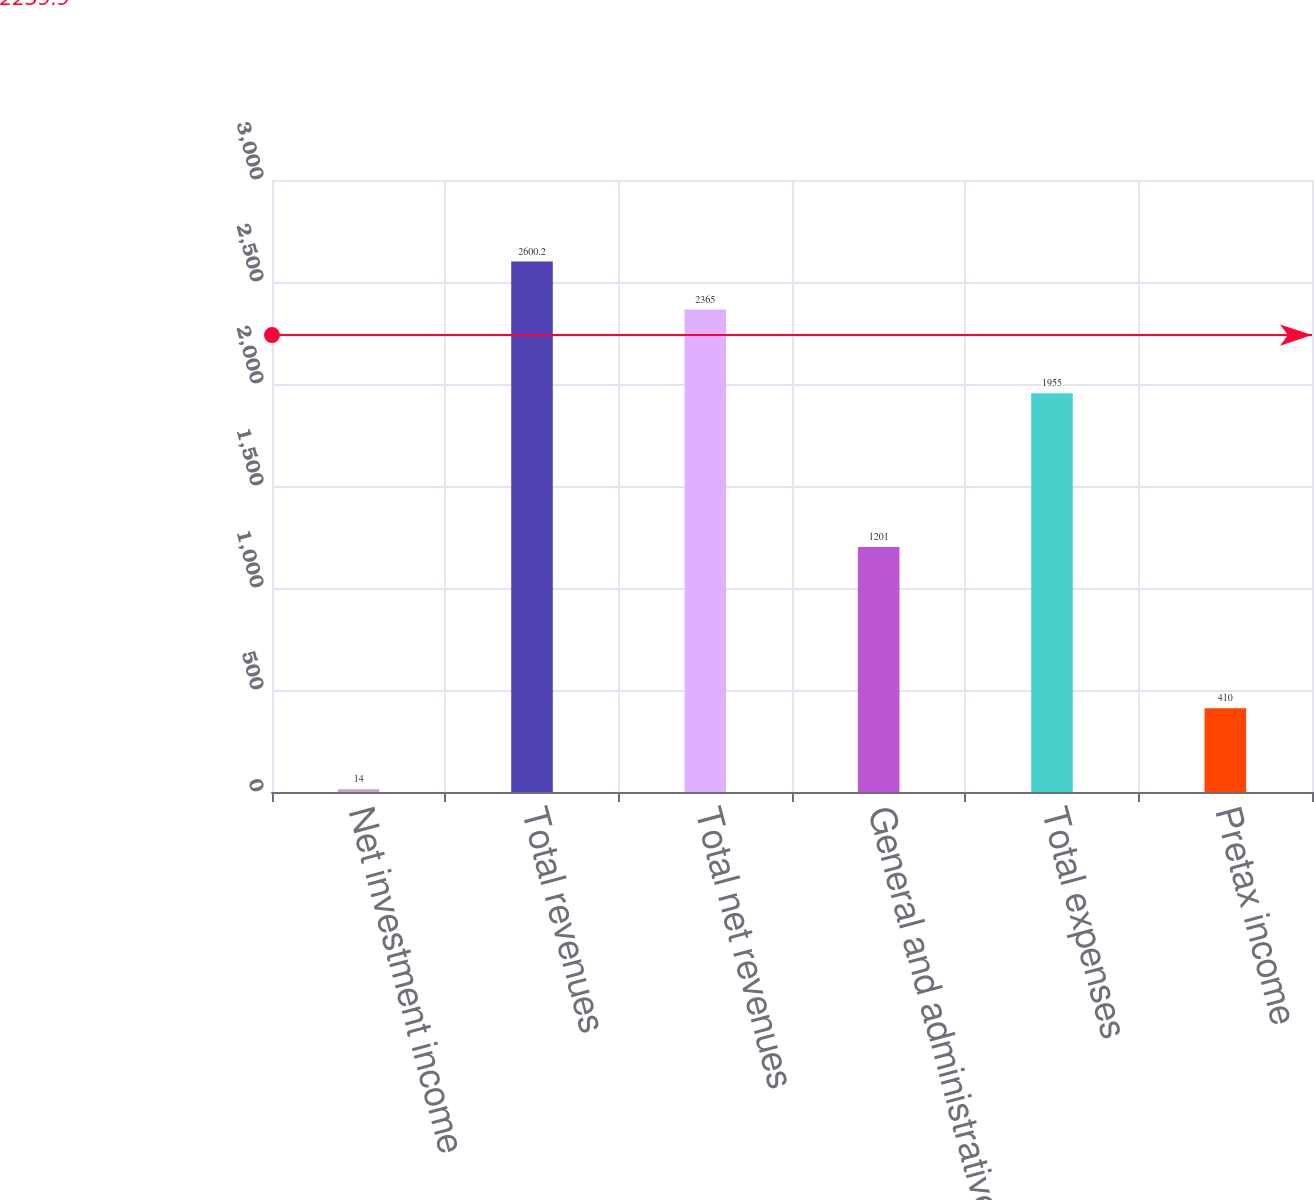Convert chart. <chart><loc_0><loc_0><loc_500><loc_500><bar_chart><fcel>Net investment income<fcel>Total revenues<fcel>Total net revenues<fcel>General and administrative<fcel>Total expenses<fcel>Pretax income<nl><fcel>14<fcel>2600.2<fcel>2365<fcel>1201<fcel>1955<fcel>410<nl></chart> 